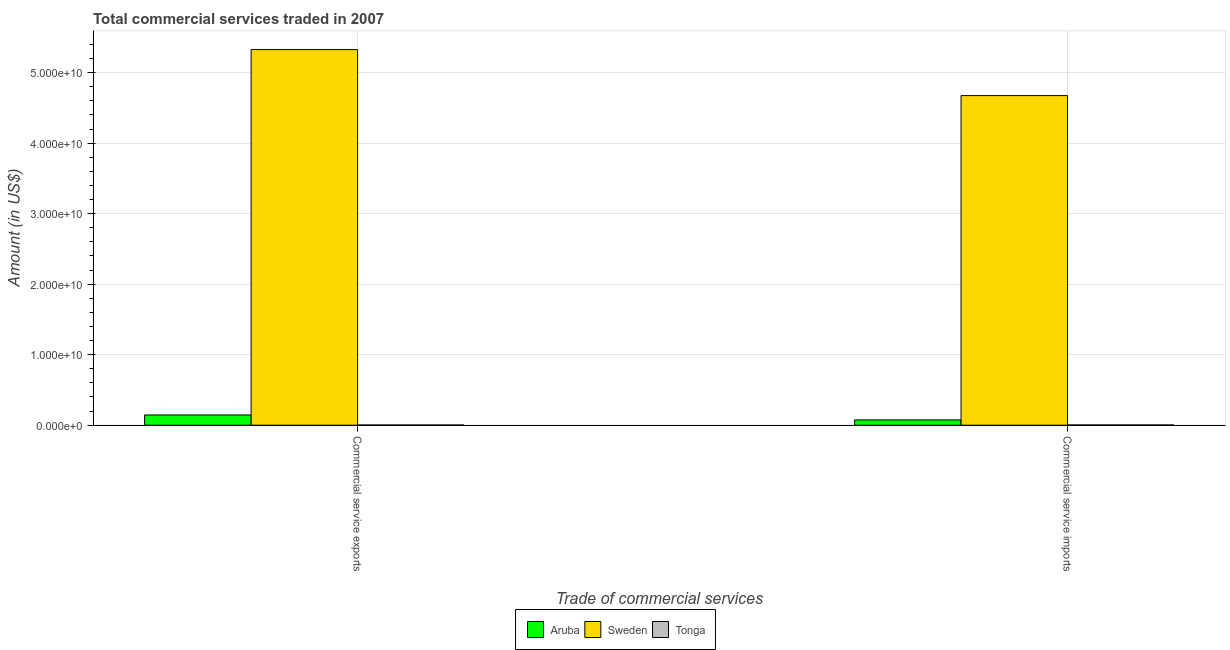How many different coloured bars are there?
Provide a short and direct response. 3. Are the number of bars per tick equal to the number of legend labels?
Ensure brevity in your answer.  Yes. Are the number of bars on each tick of the X-axis equal?
Offer a terse response. Yes. How many bars are there on the 2nd tick from the left?
Make the answer very short. 3. How many bars are there on the 2nd tick from the right?
Provide a short and direct response. 3. What is the label of the 1st group of bars from the left?
Give a very brief answer. Commercial service exports. What is the amount of commercial service exports in Tonga?
Keep it short and to the point. 2.67e+07. Across all countries, what is the maximum amount of commercial service exports?
Make the answer very short. 5.33e+1. Across all countries, what is the minimum amount of commercial service exports?
Your response must be concise. 2.67e+07. In which country was the amount of commercial service exports maximum?
Ensure brevity in your answer.  Sweden. In which country was the amount of commercial service exports minimum?
Make the answer very short. Tonga. What is the total amount of commercial service imports in the graph?
Make the answer very short. 4.75e+1. What is the difference between the amount of commercial service imports in Sweden and that in Tonga?
Provide a short and direct response. 4.67e+1. What is the difference between the amount of commercial service exports in Sweden and the amount of commercial service imports in Tonga?
Your answer should be compact. 5.32e+1. What is the average amount of commercial service imports per country?
Your answer should be very brief. 1.58e+1. What is the difference between the amount of commercial service exports and amount of commercial service imports in Sweden?
Your response must be concise. 6.52e+09. In how many countries, is the amount of commercial service exports greater than 10000000000 US$?
Offer a terse response. 1. What is the ratio of the amount of commercial service imports in Sweden to that in Tonga?
Keep it short and to the point. 1337.25. Is the amount of commercial service imports in Aruba less than that in Tonga?
Keep it short and to the point. No. In how many countries, is the amount of commercial service imports greater than the average amount of commercial service imports taken over all countries?
Provide a succinct answer. 1. What does the 2nd bar from the left in Commercial service imports represents?
Keep it short and to the point. Sweden. What does the 3rd bar from the right in Commercial service exports represents?
Your answer should be very brief. Aruba. How many bars are there?
Your answer should be very brief. 6. Are all the bars in the graph horizontal?
Your answer should be compact. No. How many countries are there in the graph?
Offer a very short reply. 3. Does the graph contain grids?
Your answer should be compact. Yes. What is the title of the graph?
Offer a terse response. Total commercial services traded in 2007. What is the label or title of the X-axis?
Your response must be concise. Trade of commercial services. What is the Amount (in US$) of Aruba in Commercial service exports?
Ensure brevity in your answer.  1.45e+09. What is the Amount (in US$) in Sweden in Commercial service exports?
Provide a succinct answer. 5.33e+1. What is the Amount (in US$) in Tonga in Commercial service exports?
Offer a terse response. 2.67e+07. What is the Amount (in US$) in Aruba in Commercial service imports?
Your response must be concise. 7.51e+08. What is the Amount (in US$) in Sweden in Commercial service imports?
Make the answer very short. 4.67e+1. What is the Amount (in US$) of Tonga in Commercial service imports?
Your answer should be compact. 3.50e+07. Across all Trade of commercial services, what is the maximum Amount (in US$) of Aruba?
Give a very brief answer. 1.45e+09. Across all Trade of commercial services, what is the maximum Amount (in US$) of Sweden?
Keep it short and to the point. 5.33e+1. Across all Trade of commercial services, what is the maximum Amount (in US$) in Tonga?
Your answer should be very brief. 3.50e+07. Across all Trade of commercial services, what is the minimum Amount (in US$) in Aruba?
Give a very brief answer. 7.51e+08. Across all Trade of commercial services, what is the minimum Amount (in US$) of Sweden?
Your answer should be very brief. 4.67e+1. Across all Trade of commercial services, what is the minimum Amount (in US$) of Tonga?
Your response must be concise. 2.67e+07. What is the total Amount (in US$) of Aruba in the graph?
Provide a succinct answer. 2.20e+09. What is the total Amount (in US$) in Sweden in the graph?
Offer a very short reply. 1.00e+11. What is the total Amount (in US$) in Tonga in the graph?
Provide a succinct answer. 6.16e+07. What is the difference between the Amount (in US$) in Aruba in Commercial service exports and that in Commercial service imports?
Provide a short and direct response. 7.01e+08. What is the difference between the Amount (in US$) in Sweden in Commercial service exports and that in Commercial service imports?
Make the answer very short. 6.52e+09. What is the difference between the Amount (in US$) in Tonga in Commercial service exports and that in Commercial service imports?
Offer a very short reply. -8.26e+06. What is the difference between the Amount (in US$) of Aruba in Commercial service exports and the Amount (in US$) of Sweden in Commercial service imports?
Your answer should be compact. -4.53e+1. What is the difference between the Amount (in US$) in Aruba in Commercial service exports and the Amount (in US$) in Tonga in Commercial service imports?
Give a very brief answer. 1.42e+09. What is the difference between the Amount (in US$) in Sweden in Commercial service exports and the Amount (in US$) in Tonga in Commercial service imports?
Provide a short and direct response. 5.32e+1. What is the average Amount (in US$) in Aruba per Trade of commercial services?
Offer a terse response. 1.10e+09. What is the average Amount (in US$) in Sweden per Trade of commercial services?
Give a very brief answer. 5.00e+1. What is the average Amount (in US$) of Tonga per Trade of commercial services?
Your response must be concise. 3.08e+07. What is the difference between the Amount (in US$) in Aruba and Amount (in US$) in Sweden in Commercial service exports?
Keep it short and to the point. -5.18e+1. What is the difference between the Amount (in US$) in Aruba and Amount (in US$) in Tonga in Commercial service exports?
Your answer should be compact. 1.43e+09. What is the difference between the Amount (in US$) of Sweden and Amount (in US$) of Tonga in Commercial service exports?
Give a very brief answer. 5.32e+1. What is the difference between the Amount (in US$) of Aruba and Amount (in US$) of Sweden in Commercial service imports?
Keep it short and to the point. -4.60e+1. What is the difference between the Amount (in US$) of Aruba and Amount (in US$) of Tonga in Commercial service imports?
Ensure brevity in your answer.  7.16e+08. What is the difference between the Amount (in US$) of Sweden and Amount (in US$) of Tonga in Commercial service imports?
Provide a succinct answer. 4.67e+1. What is the ratio of the Amount (in US$) in Aruba in Commercial service exports to that in Commercial service imports?
Your answer should be compact. 1.93. What is the ratio of the Amount (in US$) in Sweden in Commercial service exports to that in Commercial service imports?
Ensure brevity in your answer.  1.14. What is the ratio of the Amount (in US$) in Tonga in Commercial service exports to that in Commercial service imports?
Make the answer very short. 0.76. What is the difference between the highest and the second highest Amount (in US$) of Aruba?
Ensure brevity in your answer.  7.01e+08. What is the difference between the highest and the second highest Amount (in US$) in Sweden?
Your answer should be compact. 6.52e+09. What is the difference between the highest and the second highest Amount (in US$) in Tonga?
Keep it short and to the point. 8.26e+06. What is the difference between the highest and the lowest Amount (in US$) of Aruba?
Offer a terse response. 7.01e+08. What is the difference between the highest and the lowest Amount (in US$) in Sweden?
Provide a succinct answer. 6.52e+09. What is the difference between the highest and the lowest Amount (in US$) of Tonga?
Your response must be concise. 8.26e+06. 